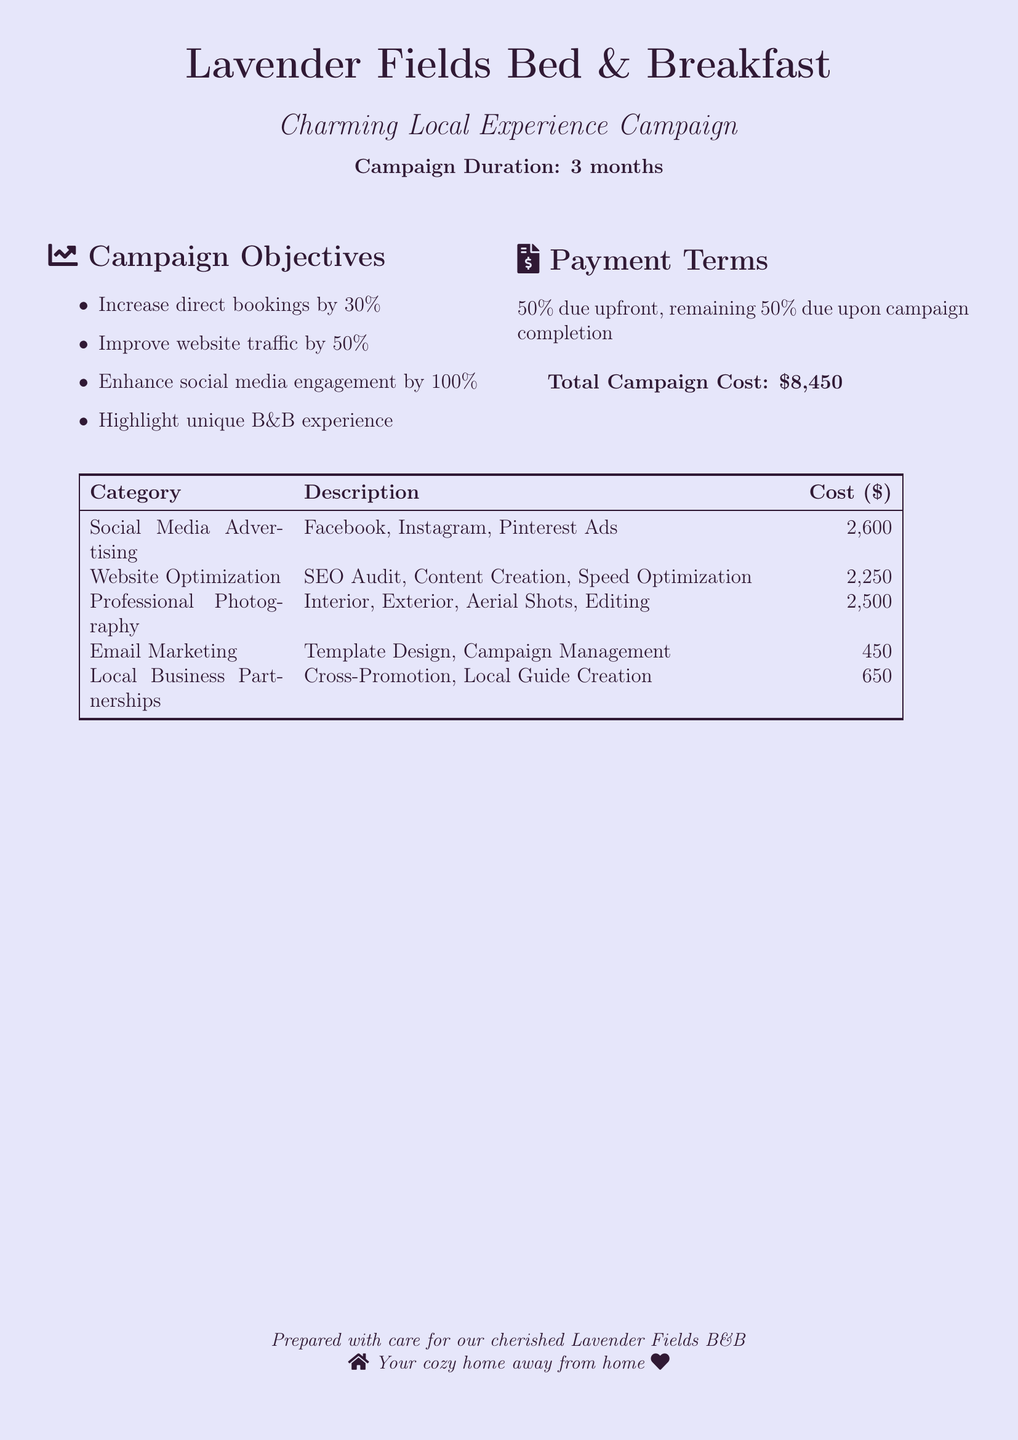what is the campaign name? The campaign name is specifically mentioned as "Charming Local Experience Campaign."
Answer: Charming Local Experience Campaign how long is the campaign duration? The duration is indicated clearly in the document as being for 3 months.
Answer: 3 months what is the total campaign cost? The total cost for the campaign is provided as $8,450, which summarizes all expenses.
Answer: $8,450 what is the payment term for this campaign? The payment terms state that 50% is due upfront and the remaining 50% upon completion of the campaign.
Answer: 50% due upfront, remaining 50% due upon campaign completion which platform had the highest advertising cost? The highest advertising cost listed in the social media section corresponds to Facebook Ads, which is $1,200.
Answer: Facebook Ads how many blog posts are included in content creation? The content creation item states that it includes 10 blog posts about local attractions and B&B experiences.
Answer: 10 what is the objective related to social media engagement? One of the campaign objectives explicitly mentions enhancing social media engagement by 100%.
Answer: Enhance social media engagement by 100% which category has the least total cost? The least total cost comes from Email Marketing, as the combined cost of services in that category is $450.
Answer: Email Marketing who is the provider for the SEO audit? The document identifies LocalSEO Solutions as the provider for the SEO Audit service included in the campaign.
Answer: LocalSEO Solutions 